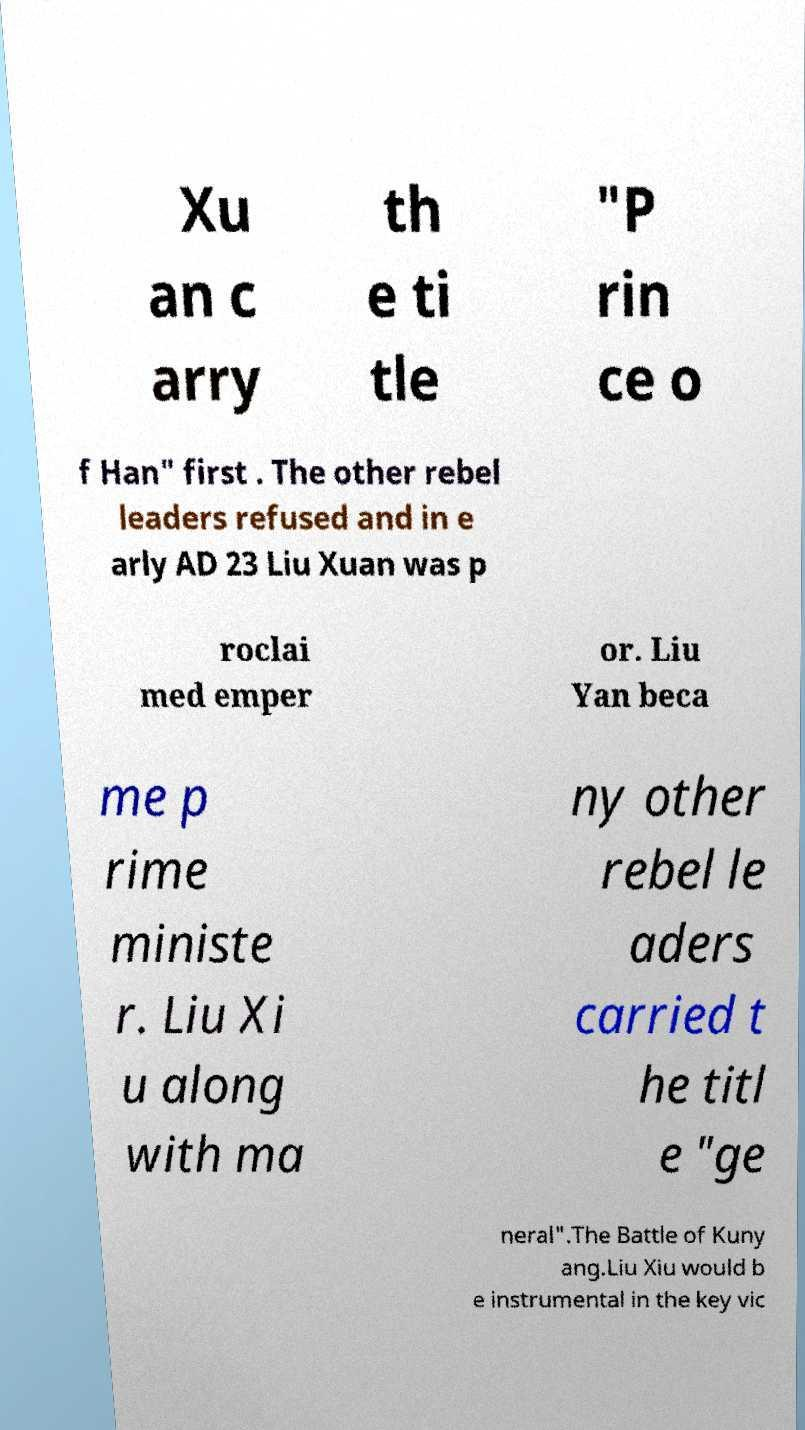What messages or text are displayed in this image? I need them in a readable, typed format. Xu an c arry th e ti tle "P rin ce o f Han" first . The other rebel leaders refused and in e arly AD 23 Liu Xuan was p roclai med emper or. Liu Yan beca me p rime ministe r. Liu Xi u along with ma ny other rebel le aders carried t he titl e "ge neral".The Battle of Kuny ang.Liu Xiu would b e instrumental in the key vic 